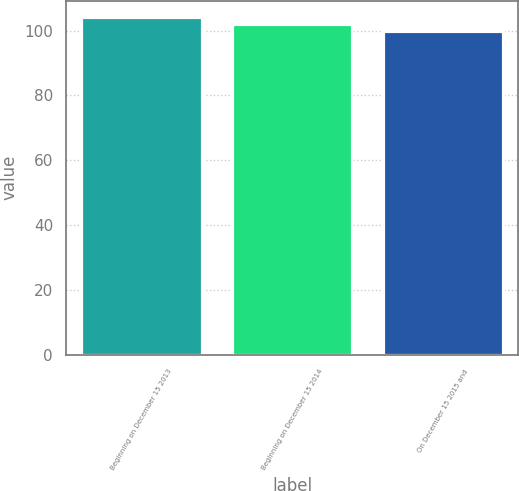<chart> <loc_0><loc_0><loc_500><loc_500><bar_chart><fcel>Beginning on December 15 2013<fcel>Beginning on December 15 2014<fcel>On December 15 2015 and<nl><fcel>104.06<fcel>102.03<fcel>100<nl></chart> 